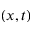Convert formula to latex. <formula><loc_0><loc_0><loc_500><loc_500>( x , t )</formula> 